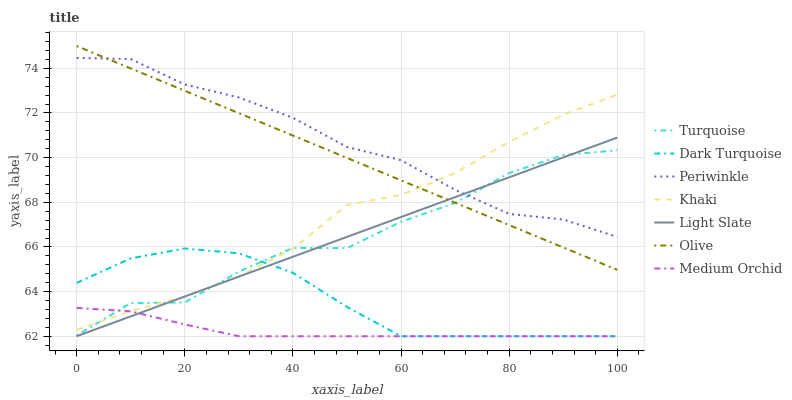Does Medium Orchid have the minimum area under the curve?
Answer yes or no. Yes. Does Periwinkle have the maximum area under the curve?
Answer yes or no. Yes. Does Khaki have the minimum area under the curve?
Answer yes or no. No. Does Khaki have the maximum area under the curve?
Answer yes or no. No. Is Olive the smoothest?
Answer yes or no. Yes. Is Turquoise the roughest?
Answer yes or no. Yes. Is Khaki the smoothest?
Answer yes or no. No. Is Khaki the roughest?
Answer yes or no. No. Does Khaki have the lowest value?
Answer yes or no. No. Does Khaki have the highest value?
Answer yes or no. No. Is Medium Orchid less than Periwinkle?
Answer yes or no. Yes. Is Olive greater than Dark Turquoise?
Answer yes or no. Yes. Does Medium Orchid intersect Periwinkle?
Answer yes or no. No. 